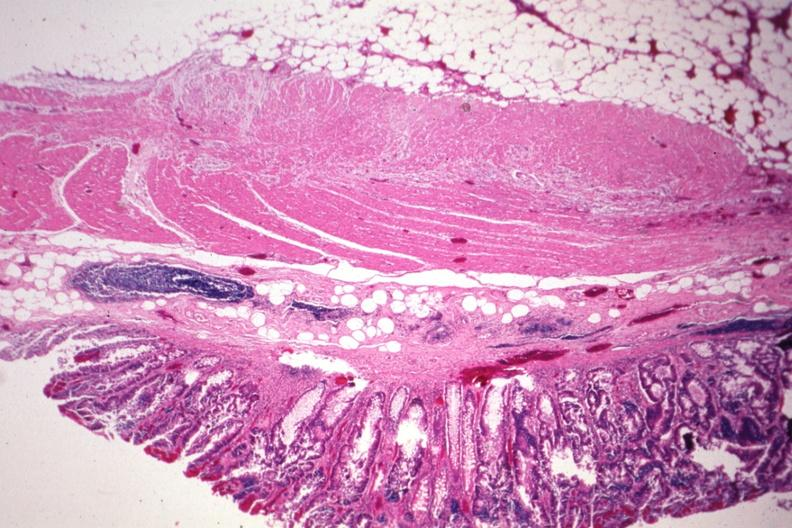s gastrointestinal present?
Answer the question using a single word or phrase. Yes 